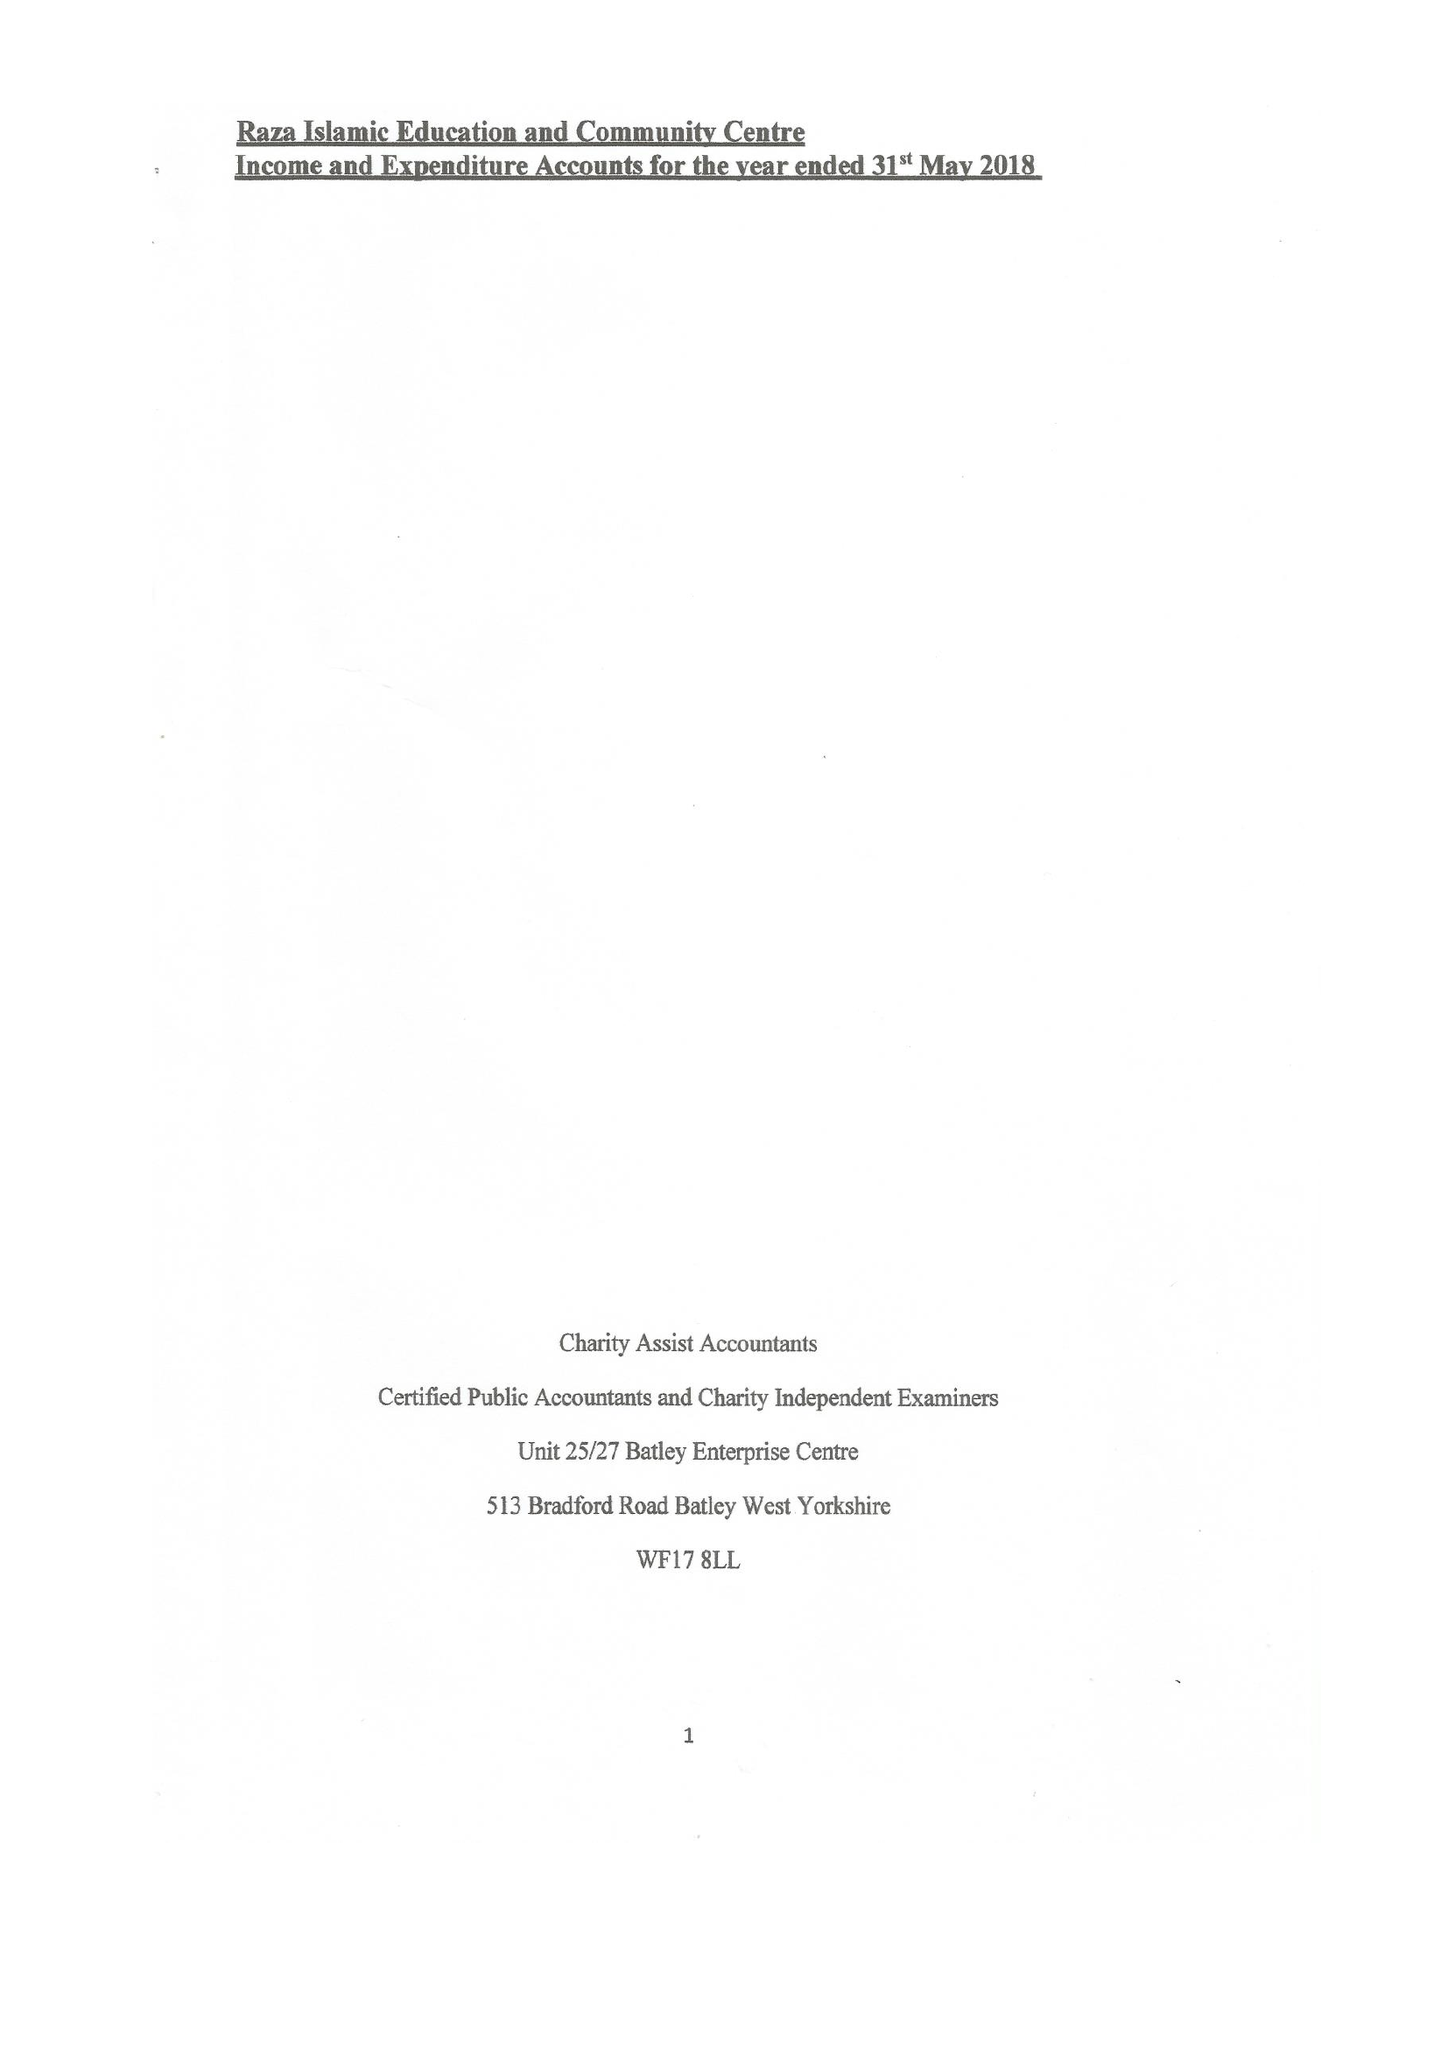What is the value for the report_date?
Answer the question using a single word or phrase. 2018-05-31 